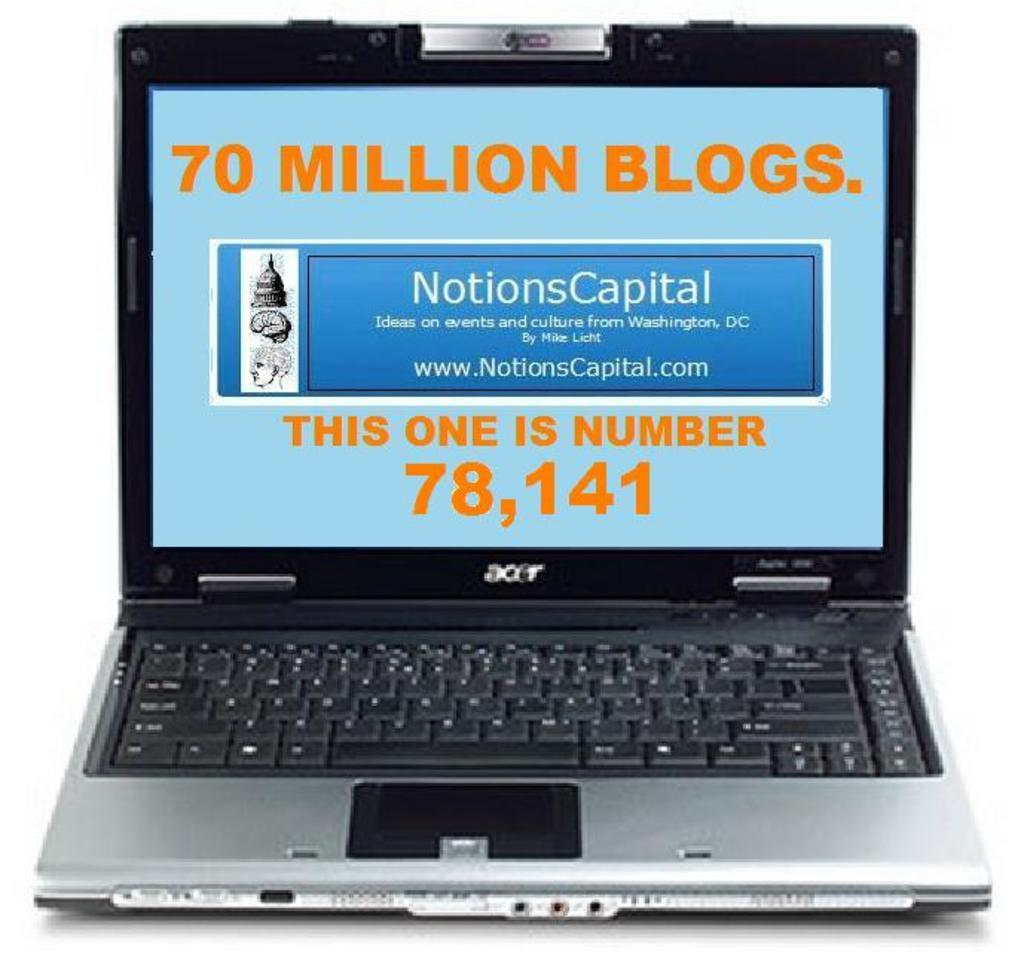<image>
Relay a brief, clear account of the picture shown. a Notions Capital ad is on the computer screen 